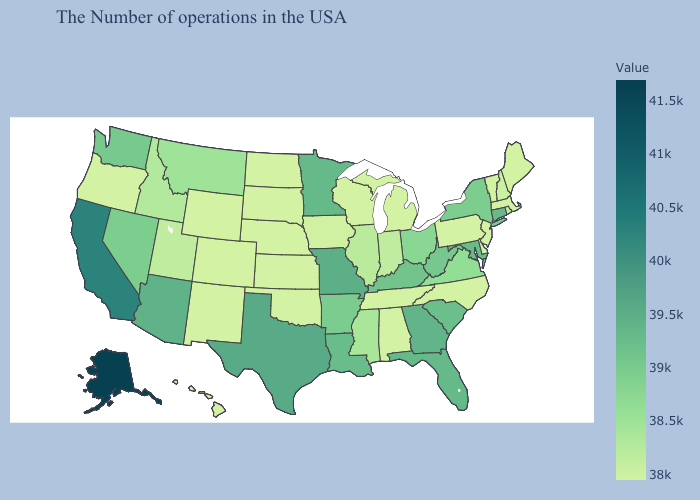Does Connecticut have the highest value in the Northeast?
Be succinct. Yes. Among the states that border Utah , which have the lowest value?
Give a very brief answer. Wyoming, Colorado, New Mexico. Among the states that border Mississippi , which have the highest value?
Quick response, please. Louisiana. Does Alabama have the lowest value in the USA?
Answer briefly. Yes. Does Kansas have the lowest value in the MidWest?
Write a very short answer. Yes. 